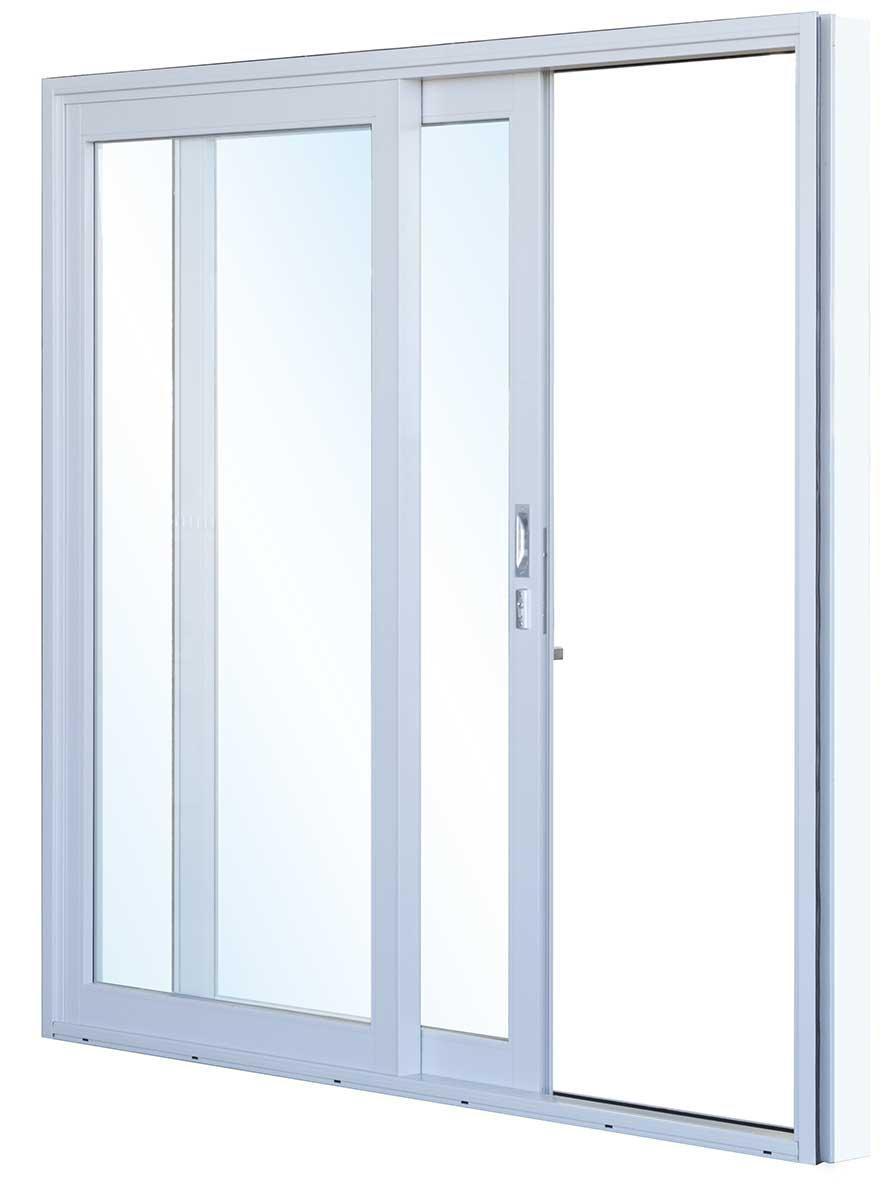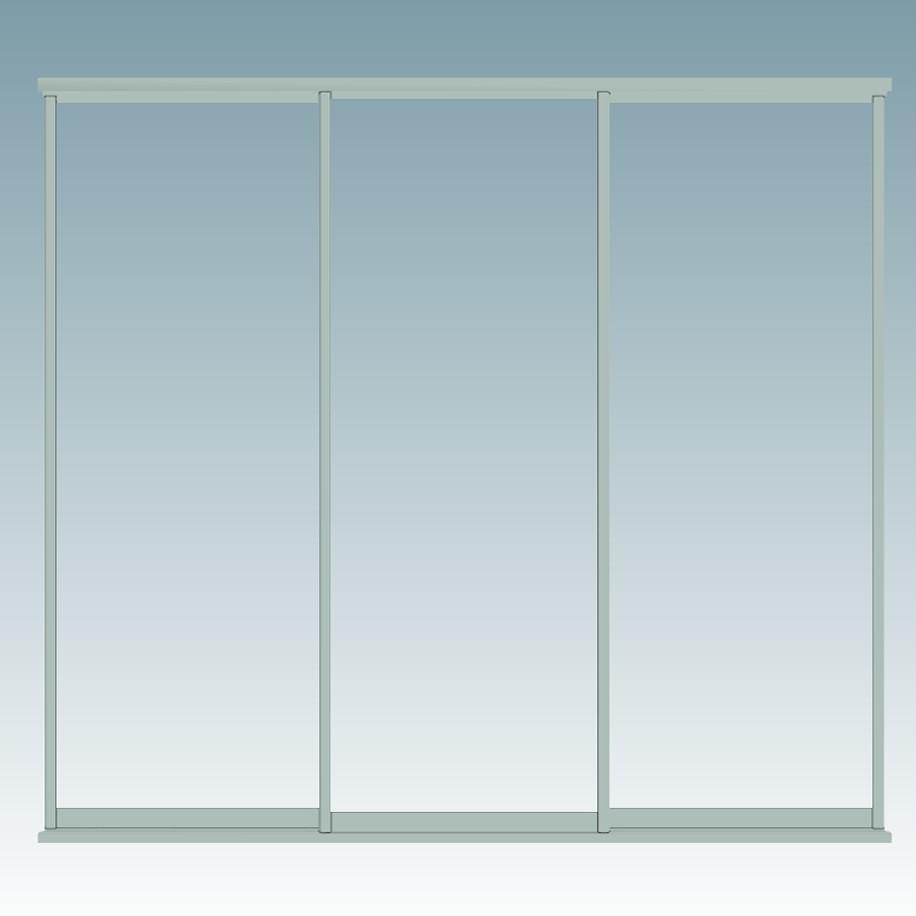The first image is the image on the left, the second image is the image on the right. Considering the images on both sides, is "In the image to the right, the window's handle is black, and large enough for a solid grip." valid? Answer yes or no. No. 